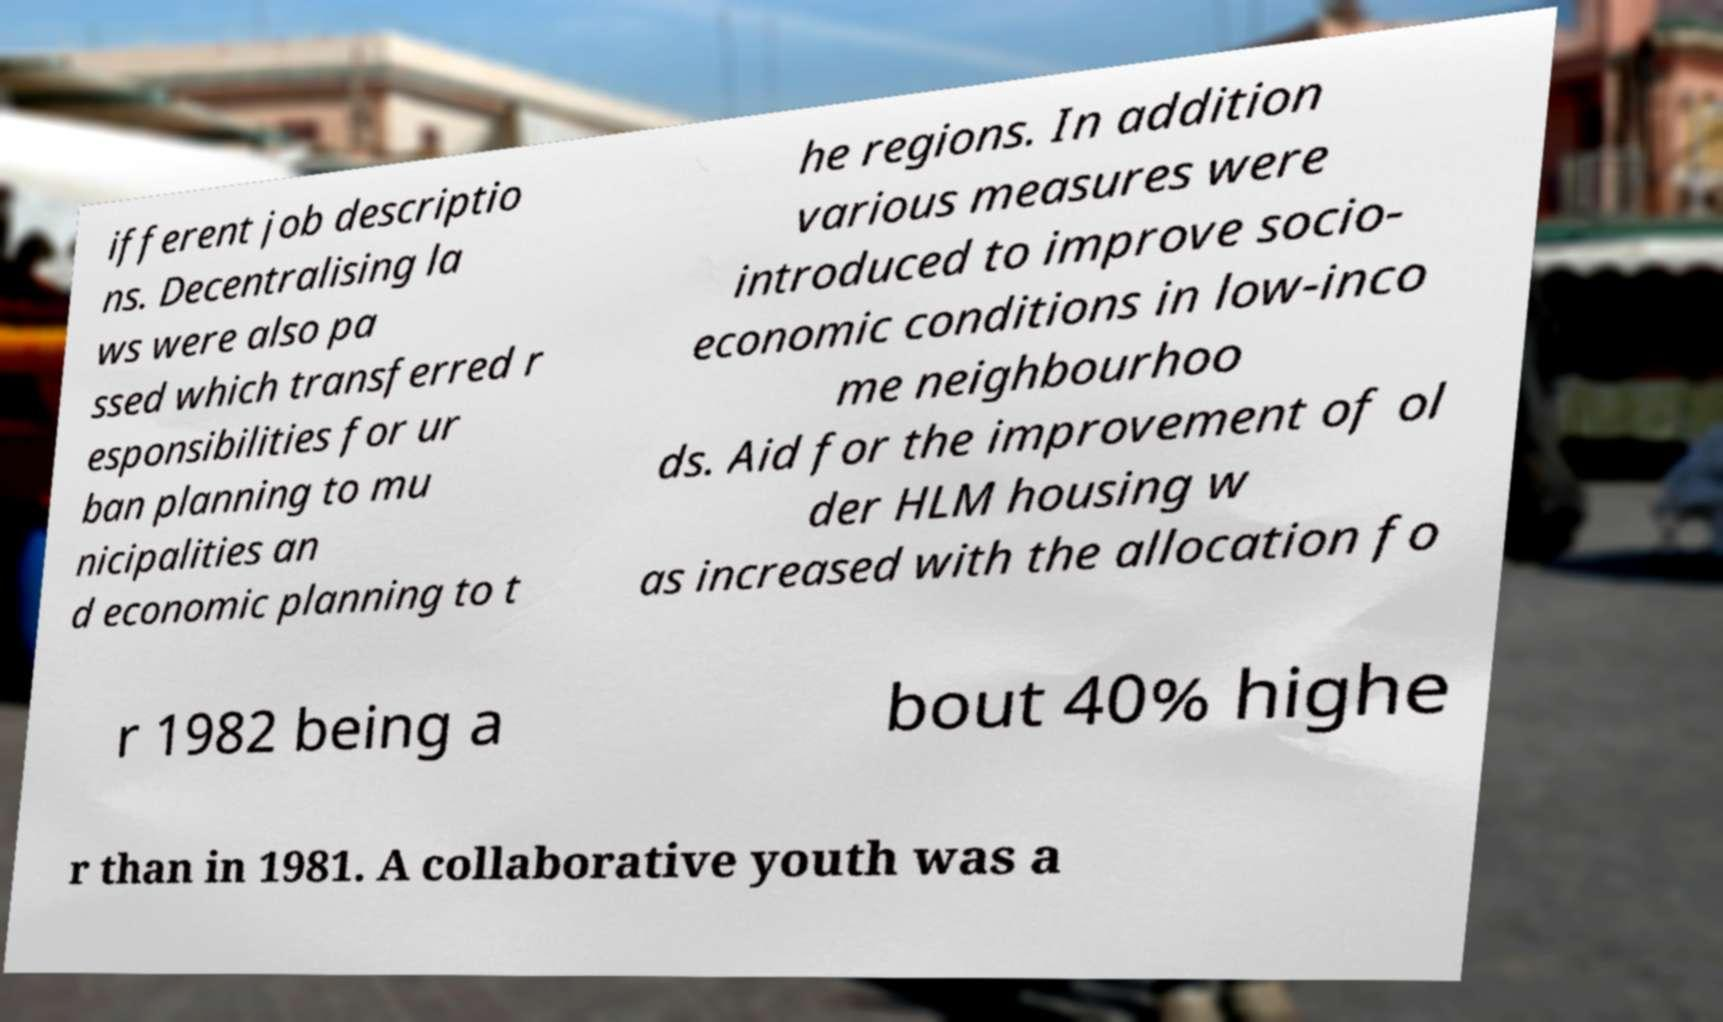Can you read and provide the text displayed in the image?This photo seems to have some interesting text. Can you extract and type it out for me? ifferent job descriptio ns. Decentralising la ws were also pa ssed which transferred r esponsibilities for ur ban planning to mu nicipalities an d economic planning to t he regions. In addition various measures were introduced to improve socio- economic conditions in low-inco me neighbourhoo ds. Aid for the improvement of ol der HLM housing w as increased with the allocation fo r 1982 being a bout 40% highe r than in 1981. A collaborative youth was a 